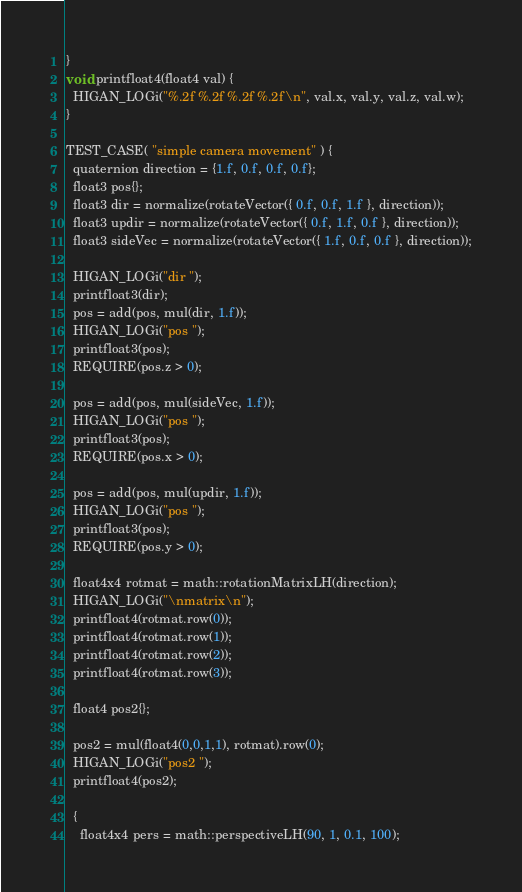<code> <loc_0><loc_0><loc_500><loc_500><_C++_>}
void printfloat4(float4 val) {
  HIGAN_LOGi("%.2f %.2f %.2f %.2f\n", val.x, val.y, val.z, val.w);
}

TEST_CASE( "simple camera movement" ) {
  quaternion direction = {1.f, 0.f, 0.f, 0.f};
  float3 pos{};
  float3 dir = normalize(rotateVector({ 0.f, 0.f, 1.f }, direction));
  float3 updir = normalize(rotateVector({ 0.f, 1.f, 0.f }, direction));
  float3 sideVec = normalize(rotateVector({ 1.f, 0.f, 0.f }, direction));

  HIGAN_LOGi("dir ");
  printfloat3(dir);
  pos = add(pos, mul(dir, 1.f));
  HIGAN_LOGi("pos ");
  printfloat3(pos);
  REQUIRE(pos.z > 0);

  pos = add(pos, mul(sideVec, 1.f));
  HIGAN_LOGi("pos ");
  printfloat3(pos);
  REQUIRE(pos.x > 0);

  pos = add(pos, mul(updir, 1.f));
  HIGAN_LOGi("pos ");
  printfloat3(pos);
  REQUIRE(pos.y > 0);

  float4x4 rotmat = math::rotationMatrixLH(direction);
  HIGAN_LOGi("\nmatrix\n");
  printfloat4(rotmat.row(0));
  printfloat4(rotmat.row(1));
  printfloat4(rotmat.row(2));
  printfloat4(rotmat.row(3));

  float4 pos2{};

  pos2 = mul(float4(0,0,1,1), rotmat).row(0);
  HIGAN_LOGi("pos2 ");
  printfloat4(pos2);

  {
    float4x4 pers = math::perspectiveLH(90, 1, 0.1, 100);</code> 